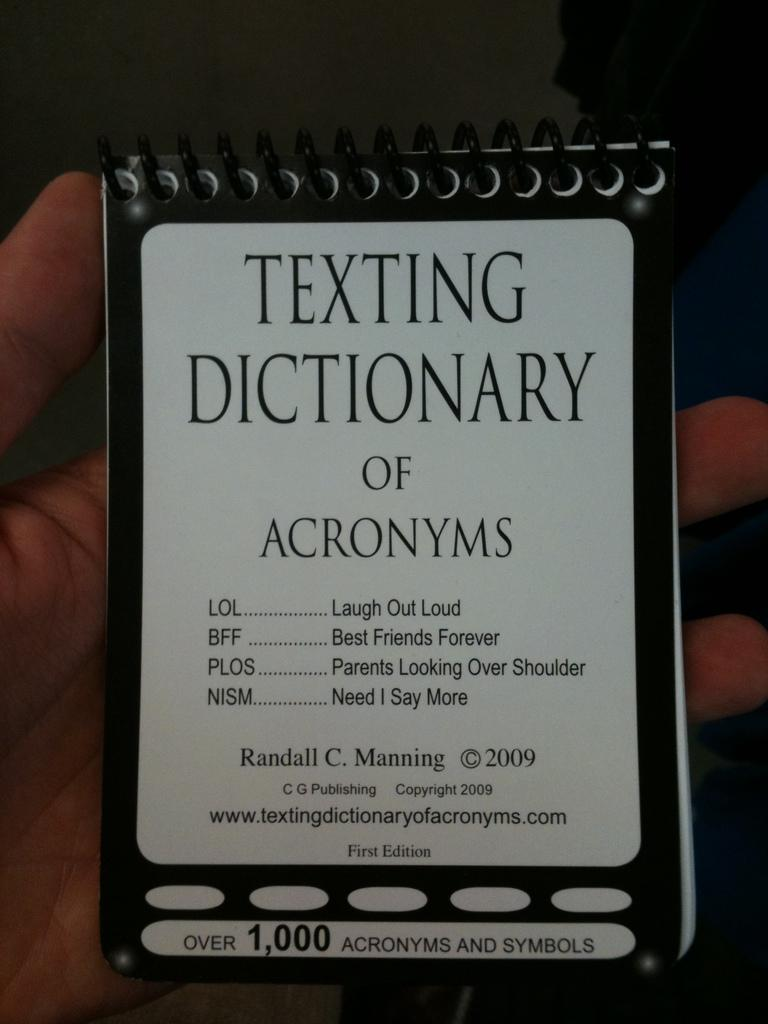What is being held by the hand in the image? The hand is holding a book. What can be seen on the book? There is writing on the book. What is the color of the writing on the book? The writing on the book is in black color. How many children are visible in the image? There are no children present in the image; it only features a hand holding a book. Is there a ghost interacting with the hand in the image? There is no ghost present in the image; it only features a hand holding a book. 